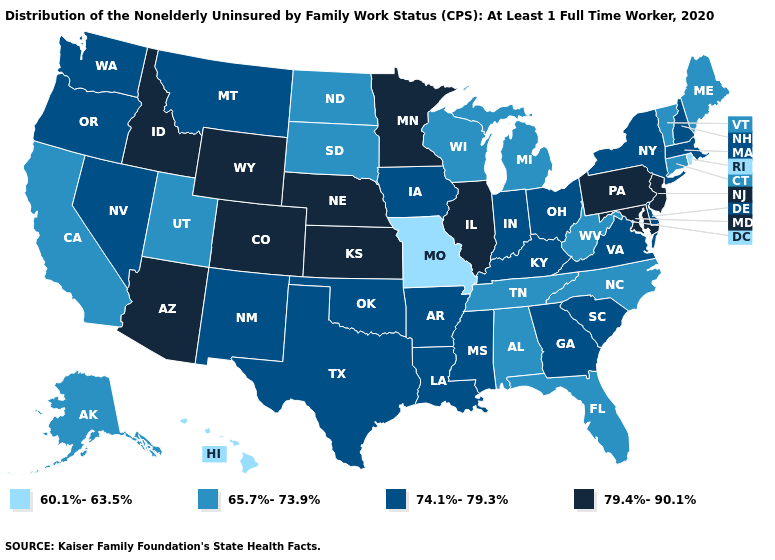Which states hav the highest value in the West?
Concise answer only. Arizona, Colorado, Idaho, Wyoming. Name the states that have a value in the range 60.1%-63.5%?
Short answer required. Hawaii, Missouri, Rhode Island. Which states have the lowest value in the South?
Be succinct. Alabama, Florida, North Carolina, Tennessee, West Virginia. Among the states that border California , which have the highest value?
Be succinct. Arizona. What is the value of New Mexico?
Short answer required. 74.1%-79.3%. What is the value of Minnesota?
Answer briefly. 79.4%-90.1%. What is the value of Washington?
Give a very brief answer. 74.1%-79.3%. Does the first symbol in the legend represent the smallest category?
Be succinct. Yes. Name the states that have a value in the range 79.4%-90.1%?
Quick response, please. Arizona, Colorado, Idaho, Illinois, Kansas, Maryland, Minnesota, Nebraska, New Jersey, Pennsylvania, Wyoming. Among the states that border South Carolina , which have the lowest value?
Give a very brief answer. North Carolina. What is the value of South Carolina?
Short answer required. 74.1%-79.3%. Does Alaska have the highest value in the West?
Answer briefly. No. Among the states that border Arkansas , does Missouri have the highest value?
Give a very brief answer. No. Does Ohio have the lowest value in the USA?
Be succinct. No. Does Alabama have the highest value in the USA?
Answer briefly. No. 